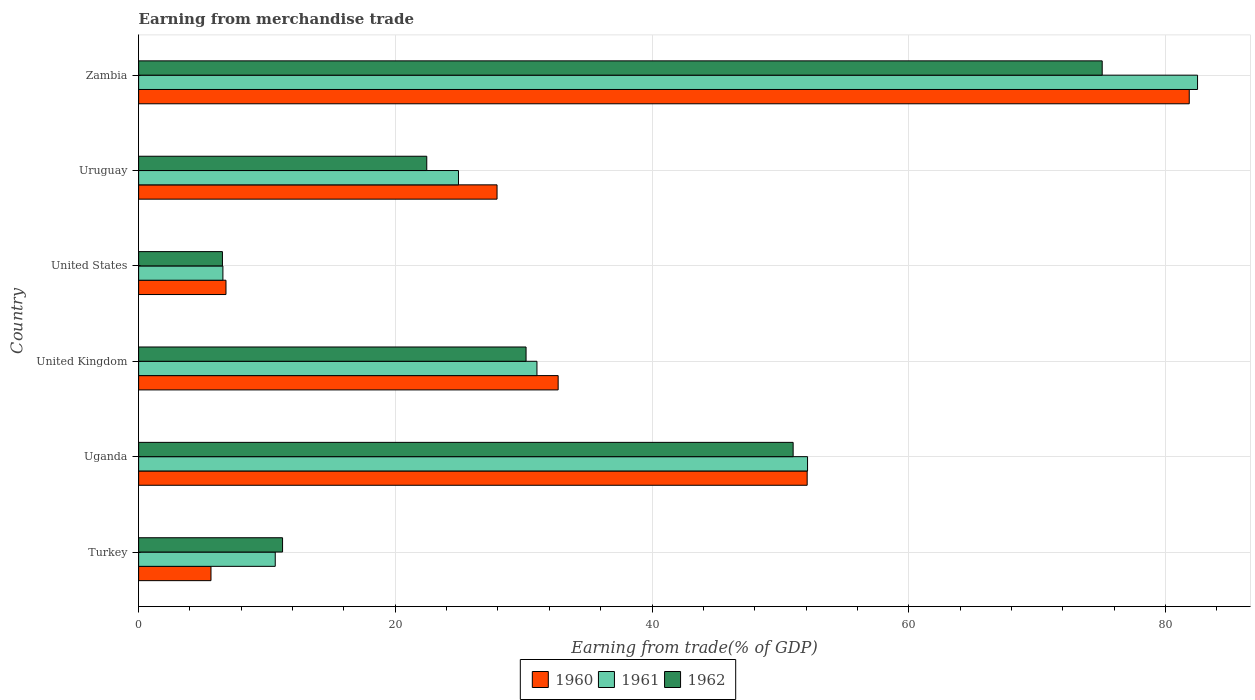How many different coloured bars are there?
Make the answer very short. 3. How many groups of bars are there?
Ensure brevity in your answer.  6. Are the number of bars on each tick of the Y-axis equal?
Offer a very short reply. Yes. How many bars are there on the 2nd tick from the bottom?
Your response must be concise. 3. In how many cases, is the number of bars for a given country not equal to the number of legend labels?
Provide a succinct answer. 0. What is the earnings from trade in 1960 in Turkey?
Your answer should be compact. 5.64. Across all countries, what is the maximum earnings from trade in 1962?
Ensure brevity in your answer.  75.08. Across all countries, what is the minimum earnings from trade in 1960?
Make the answer very short. 5.64. In which country was the earnings from trade in 1962 maximum?
Your answer should be very brief. Zambia. What is the total earnings from trade in 1960 in the graph?
Your answer should be compact. 207.01. What is the difference between the earnings from trade in 1961 in United States and that in Uruguay?
Your answer should be compact. -18.36. What is the difference between the earnings from trade in 1962 in United Kingdom and the earnings from trade in 1961 in United States?
Keep it short and to the point. 23.62. What is the average earnings from trade in 1960 per country?
Offer a terse response. 34.5. What is the difference between the earnings from trade in 1961 and earnings from trade in 1962 in Zambia?
Your answer should be very brief. 7.43. What is the ratio of the earnings from trade in 1962 in United Kingdom to that in United States?
Ensure brevity in your answer.  4.62. Is the difference between the earnings from trade in 1961 in Turkey and Uruguay greater than the difference between the earnings from trade in 1962 in Turkey and Uruguay?
Offer a very short reply. No. What is the difference between the highest and the second highest earnings from trade in 1961?
Your answer should be compact. 30.39. What is the difference between the highest and the lowest earnings from trade in 1962?
Provide a short and direct response. 68.55. In how many countries, is the earnings from trade in 1962 greater than the average earnings from trade in 1962 taken over all countries?
Make the answer very short. 2. Is the sum of the earnings from trade in 1962 in Turkey and United Kingdom greater than the maximum earnings from trade in 1960 across all countries?
Make the answer very short. No. What does the 3rd bar from the bottom in Uganda represents?
Your response must be concise. 1962. How many bars are there?
Keep it short and to the point. 18. How many countries are there in the graph?
Keep it short and to the point. 6. What is the difference between two consecutive major ticks on the X-axis?
Keep it short and to the point. 20. Are the values on the major ticks of X-axis written in scientific E-notation?
Keep it short and to the point. No. Does the graph contain grids?
Make the answer very short. Yes. How many legend labels are there?
Make the answer very short. 3. What is the title of the graph?
Offer a very short reply. Earning from merchandise trade. What is the label or title of the X-axis?
Ensure brevity in your answer.  Earning from trade(% of GDP). What is the label or title of the Y-axis?
Give a very brief answer. Country. What is the Earning from trade(% of GDP) of 1960 in Turkey?
Make the answer very short. 5.64. What is the Earning from trade(% of GDP) of 1961 in Turkey?
Keep it short and to the point. 10.64. What is the Earning from trade(% of GDP) of 1962 in Turkey?
Offer a terse response. 11.21. What is the Earning from trade(% of GDP) of 1960 in Uganda?
Offer a terse response. 52.09. What is the Earning from trade(% of GDP) in 1961 in Uganda?
Provide a succinct answer. 52.12. What is the Earning from trade(% of GDP) of 1962 in Uganda?
Ensure brevity in your answer.  51. What is the Earning from trade(% of GDP) of 1960 in United Kingdom?
Offer a very short reply. 32.69. What is the Earning from trade(% of GDP) in 1961 in United Kingdom?
Your answer should be compact. 31.04. What is the Earning from trade(% of GDP) of 1962 in United Kingdom?
Give a very brief answer. 30.19. What is the Earning from trade(% of GDP) in 1960 in United States?
Your answer should be compact. 6.81. What is the Earning from trade(% of GDP) in 1961 in United States?
Your answer should be compact. 6.57. What is the Earning from trade(% of GDP) of 1962 in United States?
Your answer should be very brief. 6.53. What is the Earning from trade(% of GDP) of 1960 in Uruguay?
Your response must be concise. 27.93. What is the Earning from trade(% of GDP) of 1961 in Uruguay?
Ensure brevity in your answer.  24.92. What is the Earning from trade(% of GDP) of 1962 in Uruguay?
Keep it short and to the point. 22.45. What is the Earning from trade(% of GDP) in 1960 in Zambia?
Offer a very short reply. 81.86. What is the Earning from trade(% of GDP) in 1961 in Zambia?
Your answer should be very brief. 82.51. What is the Earning from trade(% of GDP) of 1962 in Zambia?
Offer a terse response. 75.08. Across all countries, what is the maximum Earning from trade(% of GDP) in 1960?
Keep it short and to the point. 81.86. Across all countries, what is the maximum Earning from trade(% of GDP) of 1961?
Your answer should be very brief. 82.51. Across all countries, what is the maximum Earning from trade(% of GDP) in 1962?
Your answer should be compact. 75.08. Across all countries, what is the minimum Earning from trade(% of GDP) of 1960?
Your answer should be very brief. 5.64. Across all countries, what is the minimum Earning from trade(% of GDP) of 1961?
Your answer should be very brief. 6.57. Across all countries, what is the minimum Earning from trade(% of GDP) in 1962?
Your answer should be compact. 6.53. What is the total Earning from trade(% of GDP) of 1960 in the graph?
Your answer should be very brief. 207.01. What is the total Earning from trade(% of GDP) in 1961 in the graph?
Your answer should be compact. 207.8. What is the total Earning from trade(% of GDP) in 1962 in the graph?
Offer a terse response. 196.46. What is the difference between the Earning from trade(% of GDP) of 1960 in Turkey and that in Uganda?
Keep it short and to the point. -46.45. What is the difference between the Earning from trade(% of GDP) of 1961 in Turkey and that in Uganda?
Make the answer very short. -41.48. What is the difference between the Earning from trade(% of GDP) in 1962 in Turkey and that in Uganda?
Offer a very short reply. -39.78. What is the difference between the Earning from trade(% of GDP) in 1960 in Turkey and that in United Kingdom?
Ensure brevity in your answer.  -27.05. What is the difference between the Earning from trade(% of GDP) of 1961 in Turkey and that in United Kingdom?
Provide a succinct answer. -20.39. What is the difference between the Earning from trade(% of GDP) of 1962 in Turkey and that in United Kingdom?
Make the answer very short. -18.97. What is the difference between the Earning from trade(% of GDP) of 1960 in Turkey and that in United States?
Your response must be concise. -1.17. What is the difference between the Earning from trade(% of GDP) of 1961 in Turkey and that in United States?
Offer a terse response. 4.08. What is the difference between the Earning from trade(% of GDP) in 1962 in Turkey and that in United States?
Offer a very short reply. 4.68. What is the difference between the Earning from trade(% of GDP) in 1960 in Turkey and that in Uruguay?
Keep it short and to the point. -22.29. What is the difference between the Earning from trade(% of GDP) of 1961 in Turkey and that in Uruguay?
Your response must be concise. -14.28. What is the difference between the Earning from trade(% of GDP) of 1962 in Turkey and that in Uruguay?
Provide a succinct answer. -11.24. What is the difference between the Earning from trade(% of GDP) in 1960 in Turkey and that in Zambia?
Offer a very short reply. -76.22. What is the difference between the Earning from trade(% of GDP) in 1961 in Turkey and that in Zambia?
Your answer should be very brief. -71.86. What is the difference between the Earning from trade(% of GDP) of 1962 in Turkey and that in Zambia?
Your answer should be very brief. -63.86. What is the difference between the Earning from trade(% of GDP) in 1960 in Uganda and that in United Kingdom?
Keep it short and to the point. 19.4. What is the difference between the Earning from trade(% of GDP) in 1961 in Uganda and that in United Kingdom?
Your response must be concise. 21.08. What is the difference between the Earning from trade(% of GDP) of 1962 in Uganda and that in United Kingdom?
Provide a succinct answer. 20.81. What is the difference between the Earning from trade(% of GDP) in 1960 in Uganda and that in United States?
Your response must be concise. 45.28. What is the difference between the Earning from trade(% of GDP) of 1961 in Uganda and that in United States?
Your response must be concise. 45.55. What is the difference between the Earning from trade(% of GDP) in 1962 in Uganda and that in United States?
Ensure brevity in your answer.  44.47. What is the difference between the Earning from trade(% of GDP) of 1960 in Uganda and that in Uruguay?
Ensure brevity in your answer.  24.16. What is the difference between the Earning from trade(% of GDP) in 1961 in Uganda and that in Uruguay?
Your answer should be compact. 27.2. What is the difference between the Earning from trade(% of GDP) in 1962 in Uganda and that in Uruguay?
Provide a succinct answer. 28.55. What is the difference between the Earning from trade(% of GDP) of 1960 in Uganda and that in Zambia?
Your answer should be very brief. -29.77. What is the difference between the Earning from trade(% of GDP) in 1961 in Uganda and that in Zambia?
Make the answer very short. -30.39. What is the difference between the Earning from trade(% of GDP) in 1962 in Uganda and that in Zambia?
Provide a short and direct response. -24.08. What is the difference between the Earning from trade(% of GDP) in 1960 in United Kingdom and that in United States?
Ensure brevity in your answer.  25.88. What is the difference between the Earning from trade(% of GDP) in 1961 in United Kingdom and that in United States?
Keep it short and to the point. 24.47. What is the difference between the Earning from trade(% of GDP) of 1962 in United Kingdom and that in United States?
Your response must be concise. 23.66. What is the difference between the Earning from trade(% of GDP) in 1960 in United Kingdom and that in Uruguay?
Keep it short and to the point. 4.76. What is the difference between the Earning from trade(% of GDP) of 1961 in United Kingdom and that in Uruguay?
Your response must be concise. 6.11. What is the difference between the Earning from trade(% of GDP) of 1962 in United Kingdom and that in Uruguay?
Ensure brevity in your answer.  7.74. What is the difference between the Earning from trade(% of GDP) of 1960 in United Kingdom and that in Zambia?
Ensure brevity in your answer.  -49.17. What is the difference between the Earning from trade(% of GDP) in 1961 in United Kingdom and that in Zambia?
Ensure brevity in your answer.  -51.47. What is the difference between the Earning from trade(% of GDP) of 1962 in United Kingdom and that in Zambia?
Provide a short and direct response. -44.89. What is the difference between the Earning from trade(% of GDP) of 1960 in United States and that in Uruguay?
Make the answer very short. -21.12. What is the difference between the Earning from trade(% of GDP) in 1961 in United States and that in Uruguay?
Offer a terse response. -18.36. What is the difference between the Earning from trade(% of GDP) of 1962 in United States and that in Uruguay?
Your answer should be very brief. -15.92. What is the difference between the Earning from trade(% of GDP) of 1960 in United States and that in Zambia?
Your answer should be compact. -75.05. What is the difference between the Earning from trade(% of GDP) of 1961 in United States and that in Zambia?
Keep it short and to the point. -75.94. What is the difference between the Earning from trade(% of GDP) of 1962 in United States and that in Zambia?
Offer a terse response. -68.55. What is the difference between the Earning from trade(% of GDP) in 1960 in Uruguay and that in Zambia?
Your answer should be compact. -53.93. What is the difference between the Earning from trade(% of GDP) of 1961 in Uruguay and that in Zambia?
Provide a short and direct response. -57.59. What is the difference between the Earning from trade(% of GDP) of 1962 in Uruguay and that in Zambia?
Provide a succinct answer. -52.63. What is the difference between the Earning from trade(% of GDP) of 1960 in Turkey and the Earning from trade(% of GDP) of 1961 in Uganda?
Keep it short and to the point. -46.48. What is the difference between the Earning from trade(% of GDP) of 1960 in Turkey and the Earning from trade(% of GDP) of 1962 in Uganda?
Offer a terse response. -45.36. What is the difference between the Earning from trade(% of GDP) of 1961 in Turkey and the Earning from trade(% of GDP) of 1962 in Uganda?
Provide a short and direct response. -40.35. What is the difference between the Earning from trade(% of GDP) in 1960 in Turkey and the Earning from trade(% of GDP) in 1961 in United Kingdom?
Provide a succinct answer. -25.4. What is the difference between the Earning from trade(% of GDP) in 1960 in Turkey and the Earning from trade(% of GDP) in 1962 in United Kingdom?
Give a very brief answer. -24.55. What is the difference between the Earning from trade(% of GDP) of 1961 in Turkey and the Earning from trade(% of GDP) of 1962 in United Kingdom?
Your answer should be compact. -19.54. What is the difference between the Earning from trade(% of GDP) of 1960 in Turkey and the Earning from trade(% of GDP) of 1961 in United States?
Keep it short and to the point. -0.93. What is the difference between the Earning from trade(% of GDP) of 1960 in Turkey and the Earning from trade(% of GDP) of 1962 in United States?
Offer a very short reply. -0.89. What is the difference between the Earning from trade(% of GDP) in 1961 in Turkey and the Earning from trade(% of GDP) in 1962 in United States?
Your answer should be very brief. 4.11. What is the difference between the Earning from trade(% of GDP) in 1960 in Turkey and the Earning from trade(% of GDP) in 1961 in Uruguay?
Make the answer very short. -19.29. What is the difference between the Earning from trade(% of GDP) in 1960 in Turkey and the Earning from trade(% of GDP) in 1962 in Uruguay?
Ensure brevity in your answer.  -16.81. What is the difference between the Earning from trade(% of GDP) of 1961 in Turkey and the Earning from trade(% of GDP) of 1962 in Uruguay?
Make the answer very short. -11.81. What is the difference between the Earning from trade(% of GDP) of 1960 in Turkey and the Earning from trade(% of GDP) of 1961 in Zambia?
Keep it short and to the point. -76.87. What is the difference between the Earning from trade(% of GDP) in 1960 in Turkey and the Earning from trade(% of GDP) in 1962 in Zambia?
Your response must be concise. -69.44. What is the difference between the Earning from trade(% of GDP) of 1961 in Turkey and the Earning from trade(% of GDP) of 1962 in Zambia?
Make the answer very short. -64.43. What is the difference between the Earning from trade(% of GDP) of 1960 in Uganda and the Earning from trade(% of GDP) of 1961 in United Kingdom?
Give a very brief answer. 21.05. What is the difference between the Earning from trade(% of GDP) of 1960 in Uganda and the Earning from trade(% of GDP) of 1962 in United Kingdom?
Your answer should be very brief. 21.9. What is the difference between the Earning from trade(% of GDP) in 1961 in Uganda and the Earning from trade(% of GDP) in 1962 in United Kingdom?
Offer a terse response. 21.93. What is the difference between the Earning from trade(% of GDP) in 1960 in Uganda and the Earning from trade(% of GDP) in 1961 in United States?
Your answer should be compact. 45.52. What is the difference between the Earning from trade(% of GDP) in 1960 in Uganda and the Earning from trade(% of GDP) in 1962 in United States?
Keep it short and to the point. 45.56. What is the difference between the Earning from trade(% of GDP) of 1961 in Uganda and the Earning from trade(% of GDP) of 1962 in United States?
Provide a short and direct response. 45.59. What is the difference between the Earning from trade(% of GDP) in 1960 in Uganda and the Earning from trade(% of GDP) in 1961 in Uruguay?
Provide a short and direct response. 27.17. What is the difference between the Earning from trade(% of GDP) in 1960 in Uganda and the Earning from trade(% of GDP) in 1962 in Uruguay?
Your response must be concise. 29.64. What is the difference between the Earning from trade(% of GDP) in 1961 in Uganda and the Earning from trade(% of GDP) in 1962 in Uruguay?
Your answer should be compact. 29.67. What is the difference between the Earning from trade(% of GDP) in 1960 in Uganda and the Earning from trade(% of GDP) in 1961 in Zambia?
Make the answer very short. -30.42. What is the difference between the Earning from trade(% of GDP) of 1960 in Uganda and the Earning from trade(% of GDP) of 1962 in Zambia?
Provide a short and direct response. -22.99. What is the difference between the Earning from trade(% of GDP) in 1961 in Uganda and the Earning from trade(% of GDP) in 1962 in Zambia?
Your answer should be compact. -22.96. What is the difference between the Earning from trade(% of GDP) of 1960 in United Kingdom and the Earning from trade(% of GDP) of 1961 in United States?
Provide a short and direct response. 26.12. What is the difference between the Earning from trade(% of GDP) in 1960 in United Kingdom and the Earning from trade(% of GDP) in 1962 in United States?
Your response must be concise. 26.16. What is the difference between the Earning from trade(% of GDP) of 1961 in United Kingdom and the Earning from trade(% of GDP) of 1962 in United States?
Provide a succinct answer. 24.51. What is the difference between the Earning from trade(% of GDP) of 1960 in United Kingdom and the Earning from trade(% of GDP) of 1961 in Uruguay?
Your answer should be compact. 7.77. What is the difference between the Earning from trade(% of GDP) of 1960 in United Kingdom and the Earning from trade(% of GDP) of 1962 in Uruguay?
Make the answer very short. 10.24. What is the difference between the Earning from trade(% of GDP) in 1961 in United Kingdom and the Earning from trade(% of GDP) in 1962 in Uruguay?
Give a very brief answer. 8.59. What is the difference between the Earning from trade(% of GDP) in 1960 in United Kingdom and the Earning from trade(% of GDP) in 1961 in Zambia?
Keep it short and to the point. -49.82. What is the difference between the Earning from trade(% of GDP) of 1960 in United Kingdom and the Earning from trade(% of GDP) of 1962 in Zambia?
Your answer should be very brief. -42.39. What is the difference between the Earning from trade(% of GDP) in 1961 in United Kingdom and the Earning from trade(% of GDP) in 1962 in Zambia?
Provide a short and direct response. -44.04. What is the difference between the Earning from trade(% of GDP) of 1960 in United States and the Earning from trade(% of GDP) of 1961 in Uruguay?
Your response must be concise. -18.12. What is the difference between the Earning from trade(% of GDP) in 1960 in United States and the Earning from trade(% of GDP) in 1962 in Uruguay?
Offer a terse response. -15.64. What is the difference between the Earning from trade(% of GDP) in 1961 in United States and the Earning from trade(% of GDP) in 1962 in Uruguay?
Offer a terse response. -15.88. What is the difference between the Earning from trade(% of GDP) of 1960 in United States and the Earning from trade(% of GDP) of 1961 in Zambia?
Your answer should be compact. -75.7. What is the difference between the Earning from trade(% of GDP) in 1960 in United States and the Earning from trade(% of GDP) in 1962 in Zambia?
Offer a terse response. -68.27. What is the difference between the Earning from trade(% of GDP) of 1961 in United States and the Earning from trade(% of GDP) of 1962 in Zambia?
Your answer should be very brief. -68.51. What is the difference between the Earning from trade(% of GDP) in 1960 in Uruguay and the Earning from trade(% of GDP) in 1961 in Zambia?
Provide a short and direct response. -54.58. What is the difference between the Earning from trade(% of GDP) in 1960 in Uruguay and the Earning from trade(% of GDP) in 1962 in Zambia?
Your answer should be compact. -47.15. What is the difference between the Earning from trade(% of GDP) in 1961 in Uruguay and the Earning from trade(% of GDP) in 1962 in Zambia?
Keep it short and to the point. -50.16. What is the average Earning from trade(% of GDP) in 1960 per country?
Your answer should be compact. 34.5. What is the average Earning from trade(% of GDP) of 1961 per country?
Provide a short and direct response. 34.63. What is the average Earning from trade(% of GDP) of 1962 per country?
Provide a short and direct response. 32.74. What is the difference between the Earning from trade(% of GDP) in 1960 and Earning from trade(% of GDP) in 1961 in Turkey?
Your response must be concise. -5.01. What is the difference between the Earning from trade(% of GDP) of 1960 and Earning from trade(% of GDP) of 1962 in Turkey?
Keep it short and to the point. -5.58. What is the difference between the Earning from trade(% of GDP) of 1961 and Earning from trade(% of GDP) of 1962 in Turkey?
Provide a succinct answer. -0.57. What is the difference between the Earning from trade(% of GDP) of 1960 and Earning from trade(% of GDP) of 1961 in Uganda?
Ensure brevity in your answer.  -0.03. What is the difference between the Earning from trade(% of GDP) in 1960 and Earning from trade(% of GDP) in 1962 in Uganda?
Your answer should be compact. 1.09. What is the difference between the Earning from trade(% of GDP) in 1961 and Earning from trade(% of GDP) in 1962 in Uganda?
Ensure brevity in your answer.  1.12. What is the difference between the Earning from trade(% of GDP) in 1960 and Earning from trade(% of GDP) in 1961 in United Kingdom?
Provide a short and direct response. 1.65. What is the difference between the Earning from trade(% of GDP) of 1960 and Earning from trade(% of GDP) of 1962 in United Kingdom?
Provide a short and direct response. 2.5. What is the difference between the Earning from trade(% of GDP) in 1961 and Earning from trade(% of GDP) in 1962 in United Kingdom?
Your answer should be very brief. 0.85. What is the difference between the Earning from trade(% of GDP) in 1960 and Earning from trade(% of GDP) in 1961 in United States?
Offer a very short reply. 0.24. What is the difference between the Earning from trade(% of GDP) of 1960 and Earning from trade(% of GDP) of 1962 in United States?
Your response must be concise. 0.28. What is the difference between the Earning from trade(% of GDP) in 1961 and Earning from trade(% of GDP) in 1962 in United States?
Your response must be concise. 0.04. What is the difference between the Earning from trade(% of GDP) in 1960 and Earning from trade(% of GDP) in 1961 in Uruguay?
Ensure brevity in your answer.  3. What is the difference between the Earning from trade(% of GDP) in 1960 and Earning from trade(% of GDP) in 1962 in Uruguay?
Give a very brief answer. 5.48. What is the difference between the Earning from trade(% of GDP) in 1961 and Earning from trade(% of GDP) in 1962 in Uruguay?
Offer a terse response. 2.47. What is the difference between the Earning from trade(% of GDP) in 1960 and Earning from trade(% of GDP) in 1961 in Zambia?
Your answer should be compact. -0.65. What is the difference between the Earning from trade(% of GDP) in 1960 and Earning from trade(% of GDP) in 1962 in Zambia?
Your answer should be compact. 6.78. What is the difference between the Earning from trade(% of GDP) in 1961 and Earning from trade(% of GDP) in 1962 in Zambia?
Offer a very short reply. 7.43. What is the ratio of the Earning from trade(% of GDP) in 1960 in Turkey to that in Uganda?
Your answer should be very brief. 0.11. What is the ratio of the Earning from trade(% of GDP) of 1961 in Turkey to that in Uganda?
Ensure brevity in your answer.  0.2. What is the ratio of the Earning from trade(% of GDP) in 1962 in Turkey to that in Uganda?
Your answer should be compact. 0.22. What is the ratio of the Earning from trade(% of GDP) of 1960 in Turkey to that in United Kingdom?
Your answer should be very brief. 0.17. What is the ratio of the Earning from trade(% of GDP) of 1961 in Turkey to that in United Kingdom?
Offer a very short reply. 0.34. What is the ratio of the Earning from trade(% of GDP) of 1962 in Turkey to that in United Kingdom?
Ensure brevity in your answer.  0.37. What is the ratio of the Earning from trade(% of GDP) of 1960 in Turkey to that in United States?
Provide a short and direct response. 0.83. What is the ratio of the Earning from trade(% of GDP) of 1961 in Turkey to that in United States?
Give a very brief answer. 1.62. What is the ratio of the Earning from trade(% of GDP) in 1962 in Turkey to that in United States?
Offer a very short reply. 1.72. What is the ratio of the Earning from trade(% of GDP) of 1960 in Turkey to that in Uruguay?
Your answer should be compact. 0.2. What is the ratio of the Earning from trade(% of GDP) of 1961 in Turkey to that in Uruguay?
Make the answer very short. 0.43. What is the ratio of the Earning from trade(% of GDP) of 1962 in Turkey to that in Uruguay?
Offer a very short reply. 0.5. What is the ratio of the Earning from trade(% of GDP) in 1960 in Turkey to that in Zambia?
Ensure brevity in your answer.  0.07. What is the ratio of the Earning from trade(% of GDP) of 1961 in Turkey to that in Zambia?
Offer a terse response. 0.13. What is the ratio of the Earning from trade(% of GDP) of 1962 in Turkey to that in Zambia?
Provide a succinct answer. 0.15. What is the ratio of the Earning from trade(% of GDP) in 1960 in Uganda to that in United Kingdom?
Your answer should be compact. 1.59. What is the ratio of the Earning from trade(% of GDP) in 1961 in Uganda to that in United Kingdom?
Your answer should be very brief. 1.68. What is the ratio of the Earning from trade(% of GDP) in 1962 in Uganda to that in United Kingdom?
Your answer should be very brief. 1.69. What is the ratio of the Earning from trade(% of GDP) in 1960 in Uganda to that in United States?
Keep it short and to the point. 7.65. What is the ratio of the Earning from trade(% of GDP) in 1961 in Uganda to that in United States?
Your answer should be compact. 7.94. What is the ratio of the Earning from trade(% of GDP) of 1962 in Uganda to that in United States?
Provide a succinct answer. 7.81. What is the ratio of the Earning from trade(% of GDP) of 1960 in Uganda to that in Uruguay?
Make the answer very short. 1.87. What is the ratio of the Earning from trade(% of GDP) in 1961 in Uganda to that in Uruguay?
Offer a terse response. 2.09. What is the ratio of the Earning from trade(% of GDP) in 1962 in Uganda to that in Uruguay?
Your response must be concise. 2.27. What is the ratio of the Earning from trade(% of GDP) in 1960 in Uganda to that in Zambia?
Give a very brief answer. 0.64. What is the ratio of the Earning from trade(% of GDP) of 1961 in Uganda to that in Zambia?
Your response must be concise. 0.63. What is the ratio of the Earning from trade(% of GDP) of 1962 in Uganda to that in Zambia?
Give a very brief answer. 0.68. What is the ratio of the Earning from trade(% of GDP) in 1960 in United Kingdom to that in United States?
Your answer should be very brief. 4.8. What is the ratio of the Earning from trade(% of GDP) in 1961 in United Kingdom to that in United States?
Keep it short and to the point. 4.73. What is the ratio of the Earning from trade(% of GDP) of 1962 in United Kingdom to that in United States?
Your answer should be very brief. 4.62. What is the ratio of the Earning from trade(% of GDP) of 1960 in United Kingdom to that in Uruguay?
Your answer should be compact. 1.17. What is the ratio of the Earning from trade(% of GDP) of 1961 in United Kingdom to that in Uruguay?
Your response must be concise. 1.25. What is the ratio of the Earning from trade(% of GDP) in 1962 in United Kingdom to that in Uruguay?
Keep it short and to the point. 1.34. What is the ratio of the Earning from trade(% of GDP) in 1960 in United Kingdom to that in Zambia?
Provide a short and direct response. 0.4. What is the ratio of the Earning from trade(% of GDP) of 1961 in United Kingdom to that in Zambia?
Your answer should be compact. 0.38. What is the ratio of the Earning from trade(% of GDP) of 1962 in United Kingdom to that in Zambia?
Your response must be concise. 0.4. What is the ratio of the Earning from trade(% of GDP) in 1960 in United States to that in Uruguay?
Your response must be concise. 0.24. What is the ratio of the Earning from trade(% of GDP) in 1961 in United States to that in Uruguay?
Your response must be concise. 0.26. What is the ratio of the Earning from trade(% of GDP) in 1962 in United States to that in Uruguay?
Your response must be concise. 0.29. What is the ratio of the Earning from trade(% of GDP) in 1960 in United States to that in Zambia?
Keep it short and to the point. 0.08. What is the ratio of the Earning from trade(% of GDP) in 1961 in United States to that in Zambia?
Your answer should be very brief. 0.08. What is the ratio of the Earning from trade(% of GDP) in 1962 in United States to that in Zambia?
Provide a short and direct response. 0.09. What is the ratio of the Earning from trade(% of GDP) in 1960 in Uruguay to that in Zambia?
Give a very brief answer. 0.34. What is the ratio of the Earning from trade(% of GDP) in 1961 in Uruguay to that in Zambia?
Provide a succinct answer. 0.3. What is the ratio of the Earning from trade(% of GDP) of 1962 in Uruguay to that in Zambia?
Offer a terse response. 0.3. What is the difference between the highest and the second highest Earning from trade(% of GDP) of 1960?
Provide a short and direct response. 29.77. What is the difference between the highest and the second highest Earning from trade(% of GDP) of 1961?
Your answer should be very brief. 30.39. What is the difference between the highest and the second highest Earning from trade(% of GDP) of 1962?
Ensure brevity in your answer.  24.08. What is the difference between the highest and the lowest Earning from trade(% of GDP) of 1960?
Your answer should be compact. 76.22. What is the difference between the highest and the lowest Earning from trade(% of GDP) of 1961?
Offer a very short reply. 75.94. What is the difference between the highest and the lowest Earning from trade(% of GDP) in 1962?
Keep it short and to the point. 68.55. 